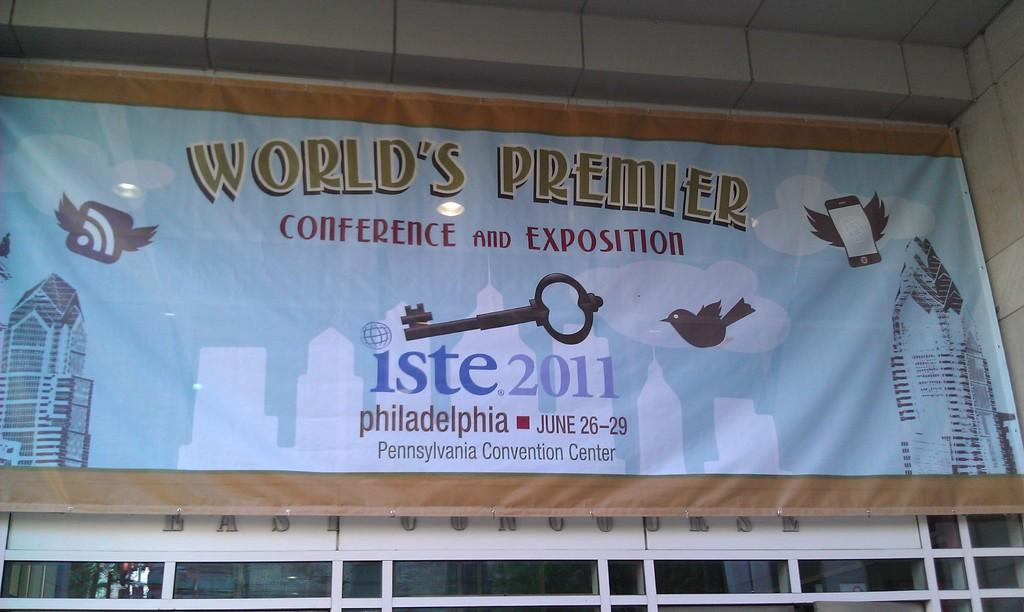<image>
Create a compact narrative representing the image presented. A banner states that Iste 2011 sponsors a conference. 